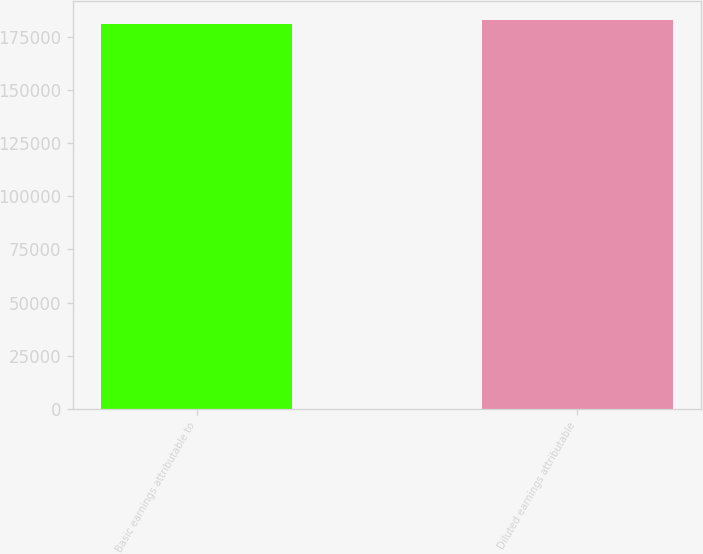Convert chart to OTSL. <chart><loc_0><loc_0><loc_500><loc_500><bar_chart><fcel>Basic earnings attributable to<fcel>Diluted earnings attributable<nl><fcel>181282<fcel>182704<nl></chart> 